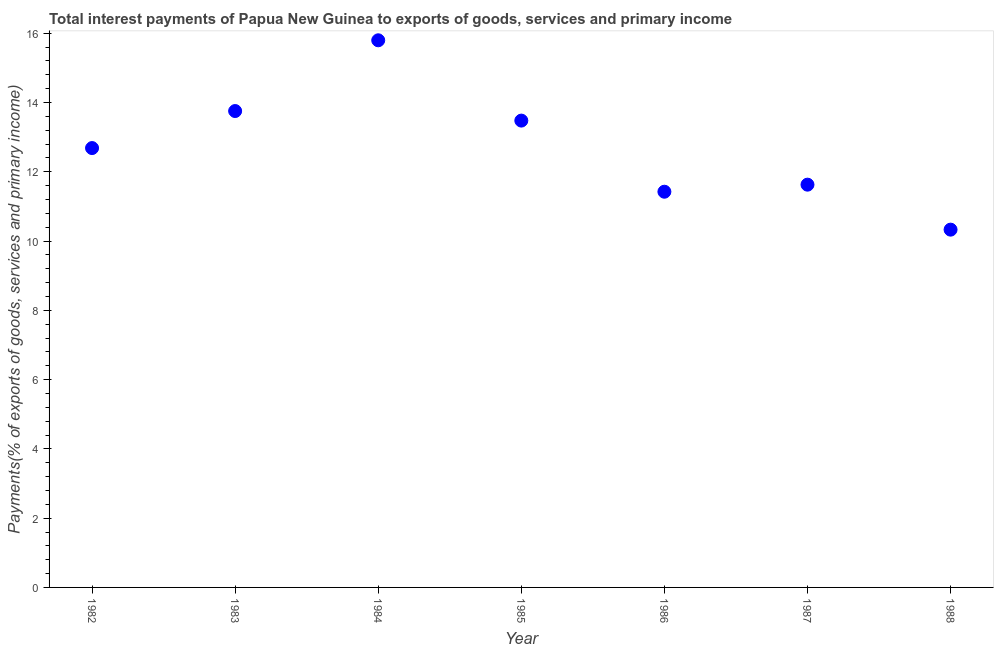What is the total interest payments on external debt in 1982?
Offer a very short reply. 12.69. Across all years, what is the maximum total interest payments on external debt?
Give a very brief answer. 15.8. Across all years, what is the minimum total interest payments on external debt?
Your answer should be very brief. 10.33. In which year was the total interest payments on external debt minimum?
Provide a succinct answer. 1988. What is the sum of the total interest payments on external debt?
Ensure brevity in your answer.  89.1. What is the difference between the total interest payments on external debt in 1984 and 1987?
Make the answer very short. 4.17. What is the average total interest payments on external debt per year?
Offer a very short reply. 12.73. What is the median total interest payments on external debt?
Ensure brevity in your answer.  12.69. What is the ratio of the total interest payments on external debt in 1985 to that in 1986?
Your answer should be compact. 1.18. What is the difference between the highest and the second highest total interest payments on external debt?
Offer a very short reply. 2.04. What is the difference between the highest and the lowest total interest payments on external debt?
Offer a very short reply. 5.47. Are the values on the major ticks of Y-axis written in scientific E-notation?
Offer a terse response. No. Does the graph contain any zero values?
Your response must be concise. No. Does the graph contain grids?
Offer a terse response. No. What is the title of the graph?
Offer a terse response. Total interest payments of Papua New Guinea to exports of goods, services and primary income. What is the label or title of the X-axis?
Keep it short and to the point. Year. What is the label or title of the Y-axis?
Give a very brief answer. Payments(% of exports of goods, services and primary income). What is the Payments(% of exports of goods, services and primary income) in 1982?
Your answer should be compact. 12.69. What is the Payments(% of exports of goods, services and primary income) in 1983?
Keep it short and to the point. 13.75. What is the Payments(% of exports of goods, services and primary income) in 1984?
Keep it short and to the point. 15.8. What is the Payments(% of exports of goods, services and primary income) in 1985?
Provide a short and direct response. 13.48. What is the Payments(% of exports of goods, services and primary income) in 1986?
Offer a very short reply. 11.43. What is the Payments(% of exports of goods, services and primary income) in 1987?
Keep it short and to the point. 11.63. What is the Payments(% of exports of goods, services and primary income) in 1988?
Your answer should be compact. 10.33. What is the difference between the Payments(% of exports of goods, services and primary income) in 1982 and 1983?
Provide a succinct answer. -1.07. What is the difference between the Payments(% of exports of goods, services and primary income) in 1982 and 1984?
Your answer should be compact. -3.11. What is the difference between the Payments(% of exports of goods, services and primary income) in 1982 and 1985?
Give a very brief answer. -0.79. What is the difference between the Payments(% of exports of goods, services and primary income) in 1982 and 1986?
Ensure brevity in your answer.  1.26. What is the difference between the Payments(% of exports of goods, services and primary income) in 1982 and 1987?
Make the answer very short. 1.06. What is the difference between the Payments(% of exports of goods, services and primary income) in 1982 and 1988?
Your answer should be very brief. 2.36. What is the difference between the Payments(% of exports of goods, services and primary income) in 1983 and 1984?
Ensure brevity in your answer.  -2.04. What is the difference between the Payments(% of exports of goods, services and primary income) in 1983 and 1985?
Provide a succinct answer. 0.28. What is the difference between the Payments(% of exports of goods, services and primary income) in 1983 and 1986?
Keep it short and to the point. 2.33. What is the difference between the Payments(% of exports of goods, services and primary income) in 1983 and 1987?
Ensure brevity in your answer.  2.13. What is the difference between the Payments(% of exports of goods, services and primary income) in 1983 and 1988?
Your answer should be compact. 3.42. What is the difference between the Payments(% of exports of goods, services and primary income) in 1984 and 1985?
Offer a terse response. 2.32. What is the difference between the Payments(% of exports of goods, services and primary income) in 1984 and 1986?
Make the answer very short. 4.37. What is the difference between the Payments(% of exports of goods, services and primary income) in 1984 and 1987?
Your answer should be compact. 4.17. What is the difference between the Payments(% of exports of goods, services and primary income) in 1984 and 1988?
Provide a short and direct response. 5.47. What is the difference between the Payments(% of exports of goods, services and primary income) in 1985 and 1986?
Make the answer very short. 2.05. What is the difference between the Payments(% of exports of goods, services and primary income) in 1985 and 1987?
Ensure brevity in your answer.  1.85. What is the difference between the Payments(% of exports of goods, services and primary income) in 1985 and 1988?
Make the answer very short. 3.15. What is the difference between the Payments(% of exports of goods, services and primary income) in 1986 and 1987?
Provide a short and direct response. -0.2. What is the difference between the Payments(% of exports of goods, services and primary income) in 1986 and 1988?
Make the answer very short. 1.09. What is the difference between the Payments(% of exports of goods, services and primary income) in 1987 and 1988?
Offer a terse response. 1.3. What is the ratio of the Payments(% of exports of goods, services and primary income) in 1982 to that in 1983?
Give a very brief answer. 0.92. What is the ratio of the Payments(% of exports of goods, services and primary income) in 1982 to that in 1984?
Make the answer very short. 0.8. What is the ratio of the Payments(% of exports of goods, services and primary income) in 1982 to that in 1985?
Your answer should be compact. 0.94. What is the ratio of the Payments(% of exports of goods, services and primary income) in 1982 to that in 1986?
Provide a succinct answer. 1.11. What is the ratio of the Payments(% of exports of goods, services and primary income) in 1982 to that in 1987?
Your answer should be very brief. 1.09. What is the ratio of the Payments(% of exports of goods, services and primary income) in 1982 to that in 1988?
Provide a short and direct response. 1.23. What is the ratio of the Payments(% of exports of goods, services and primary income) in 1983 to that in 1984?
Give a very brief answer. 0.87. What is the ratio of the Payments(% of exports of goods, services and primary income) in 1983 to that in 1986?
Provide a succinct answer. 1.2. What is the ratio of the Payments(% of exports of goods, services and primary income) in 1983 to that in 1987?
Offer a very short reply. 1.18. What is the ratio of the Payments(% of exports of goods, services and primary income) in 1983 to that in 1988?
Your answer should be very brief. 1.33. What is the ratio of the Payments(% of exports of goods, services and primary income) in 1984 to that in 1985?
Offer a terse response. 1.17. What is the ratio of the Payments(% of exports of goods, services and primary income) in 1984 to that in 1986?
Keep it short and to the point. 1.38. What is the ratio of the Payments(% of exports of goods, services and primary income) in 1984 to that in 1987?
Provide a short and direct response. 1.36. What is the ratio of the Payments(% of exports of goods, services and primary income) in 1984 to that in 1988?
Ensure brevity in your answer.  1.53. What is the ratio of the Payments(% of exports of goods, services and primary income) in 1985 to that in 1986?
Your response must be concise. 1.18. What is the ratio of the Payments(% of exports of goods, services and primary income) in 1985 to that in 1987?
Your answer should be compact. 1.16. What is the ratio of the Payments(% of exports of goods, services and primary income) in 1985 to that in 1988?
Give a very brief answer. 1.3. What is the ratio of the Payments(% of exports of goods, services and primary income) in 1986 to that in 1987?
Provide a short and direct response. 0.98. What is the ratio of the Payments(% of exports of goods, services and primary income) in 1986 to that in 1988?
Your answer should be compact. 1.11. What is the ratio of the Payments(% of exports of goods, services and primary income) in 1987 to that in 1988?
Make the answer very short. 1.13. 